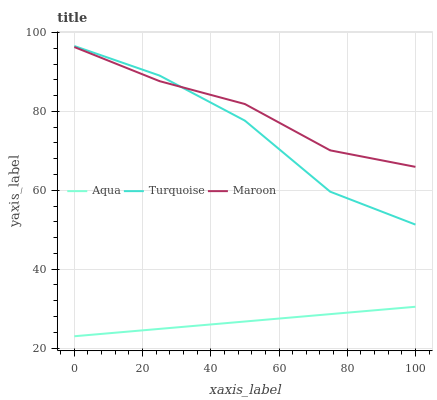Does Aqua have the minimum area under the curve?
Answer yes or no. Yes. Does Maroon have the maximum area under the curve?
Answer yes or no. Yes. Does Maroon have the minimum area under the curve?
Answer yes or no. No. Does Aqua have the maximum area under the curve?
Answer yes or no. No. Is Aqua the smoothest?
Answer yes or no. Yes. Is Turquoise the roughest?
Answer yes or no. Yes. Is Maroon the smoothest?
Answer yes or no. No. Is Maroon the roughest?
Answer yes or no. No. Does Maroon have the lowest value?
Answer yes or no. No. Does Maroon have the highest value?
Answer yes or no. No. Is Aqua less than Turquoise?
Answer yes or no. Yes. Is Turquoise greater than Aqua?
Answer yes or no. Yes. Does Aqua intersect Turquoise?
Answer yes or no. No. 